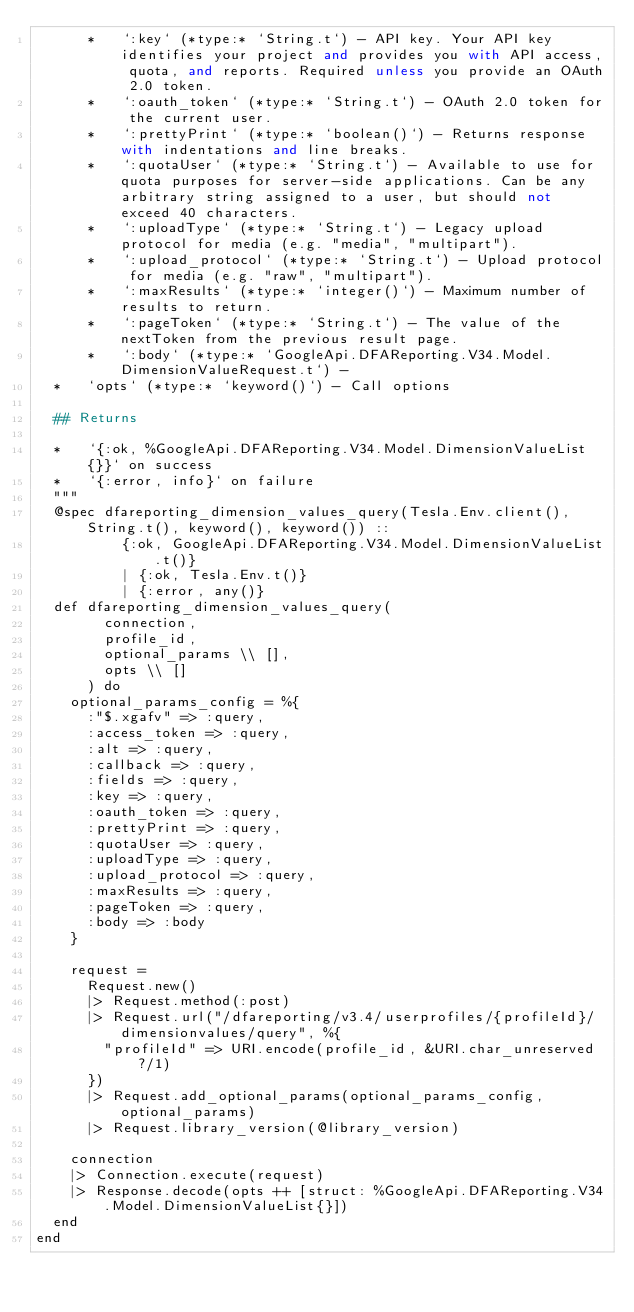Convert code to text. <code><loc_0><loc_0><loc_500><loc_500><_Elixir_>      *   `:key` (*type:* `String.t`) - API key. Your API key identifies your project and provides you with API access, quota, and reports. Required unless you provide an OAuth 2.0 token.
      *   `:oauth_token` (*type:* `String.t`) - OAuth 2.0 token for the current user.
      *   `:prettyPrint` (*type:* `boolean()`) - Returns response with indentations and line breaks.
      *   `:quotaUser` (*type:* `String.t`) - Available to use for quota purposes for server-side applications. Can be any arbitrary string assigned to a user, but should not exceed 40 characters.
      *   `:uploadType` (*type:* `String.t`) - Legacy upload protocol for media (e.g. "media", "multipart").
      *   `:upload_protocol` (*type:* `String.t`) - Upload protocol for media (e.g. "raw", "multipart").
      *   `:maxResults` (*type:* `integer()`) - Maximum number of results to return.
      *   `:pageToken` (*type:* `String.t`) - The value of the nextToken from the previous result page.
      *   `:body` (*type:* `GoogleApi.DFAReporting.V34.Model.DimensionValueRequest.t`) - 
  *   `opts` (*type:* `keyword()`) - Call options

  ## Returns

  *   `{:ok, %GoogleApi.DFAReporting.V34.Model.DimensionValueList{}}` on success
  *   `{:error, info}` on failure
  """
  @spec dfareporting_dimension_values_query(Tesla.Env.client(), String.t(), keyword(), keyword()) ::
          {:ok, GoogleApi.DFAReporting.V34.Model.DimensionValueList.t()}
          | {:ok, Tesla.Env.t()}
          | {:error, any()}
  def dfareporting_dimension_values_query(
        connection,
        profile_id,
        optional_params \\ [],
        opts \\ []
      ) do
    optional_params_config = %{
      :"$.xgafv" => :query,
      :access_token => :query,
      :alt => :query,
      :callback => :query,
      :fields => :query,
      :key => :query,
      :oauth_token => :query,
      :prettyPrint => :query,
      :quotaUser => :query,
      :uploadType => :query,
      :upload_protocol => :query,
      :maxResults => :query,
      :pageToken => :query,
      :body => :body
    }

    request =
      Request.new()
      |> Request.method(:post)
      |> Request.url("/dfareporting/v3.4/userprofiles/{profileId}/dimensionvalues/query", %{
        "profileId" => URI.encode(profile_id, &URI.char_unreserved?/1)
      })
      |> Request.add_optional_params(optional_params_config, optional_params)
      |> Request.library_version(@library_version)

    connection
    |> Connection.execute(request)
    |> Response.decode(opts ++ [struct: %GoogleApi.DFAReporting.V34.Model.DimensionValueList{}])
  end
end
</code> 